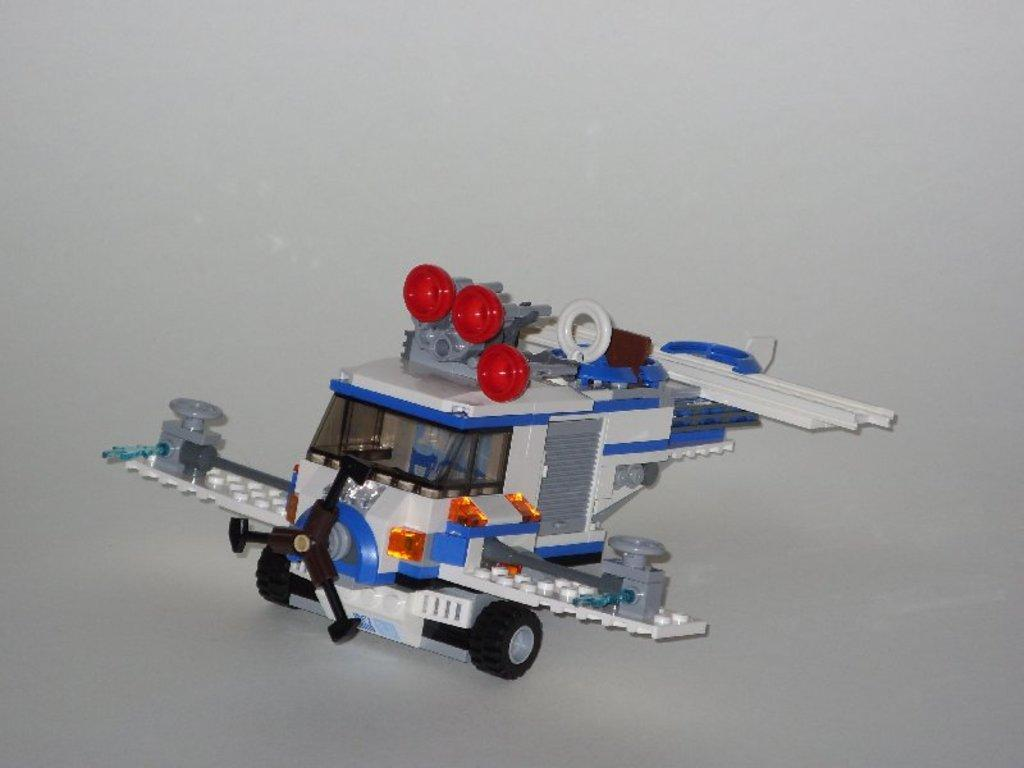What is the main subject of the image? The main subject of the image is a toy vehicle. Where is the toy vehicle located in the image? The toy vehicle is in the middle of the image. What color is the background of the image? The background of the image is white. How many fish can be seen swimming in the image? There are no fish present in the image; it features a toy vehicle in the middle of a white background. 